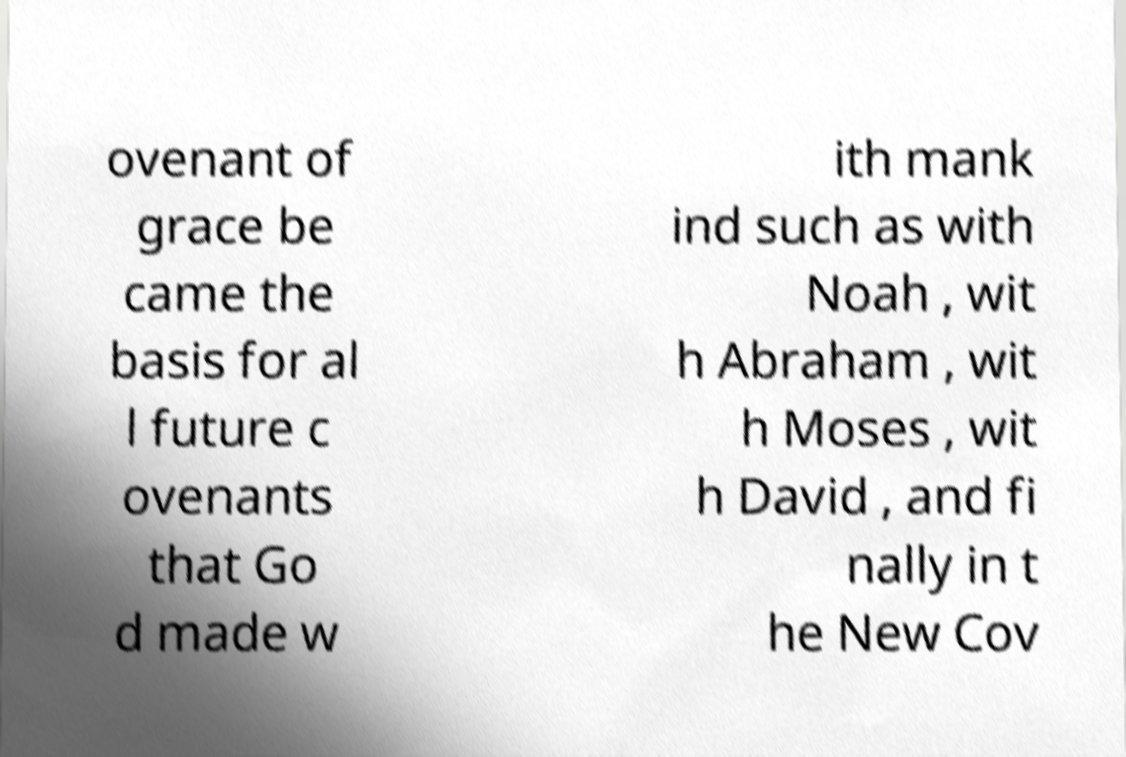Could you extract and type out the text from this image? ovenant of grace be came the basis for al l future c ovenants that Go d made w ith mank ind such as with Noah , wit h Abraham , wit h Moses , wit h David , and fi nally in t he New Cov 